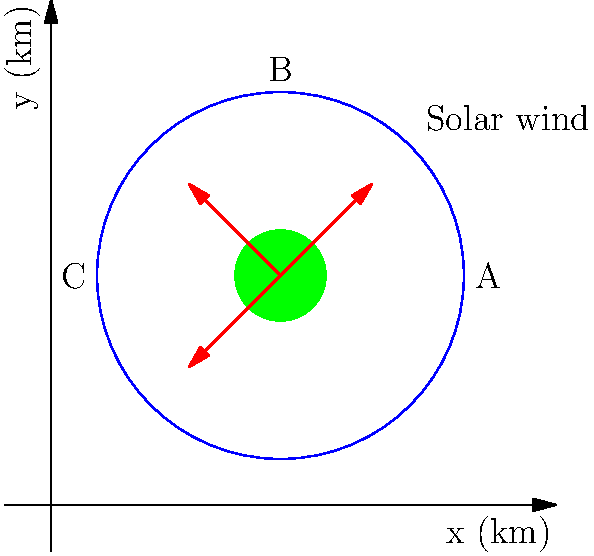A satellite orbits Earth in a circular path with radius 4 km, centered at (5,5) km. Solar wind vectors are shown in red, originating from the Earth's center. Given that the optimal orbital path should minimize exposure to solar wind, calculate the coordinates of the point on the orbit where the satellite should be positioned for minimal solar wind impact. To find the optimal position for the satellite, we need to determine the point on the orbit that is furthest from the solar wind vectors. This can be done by following these steps:

1) The solar wind vectors are pointing towards the upper-right quadrant of the orbit. Therefore, the optimal position will be in the lower-left quadrant.

2) The center of the orbit is at (5,5) km, and the radius is 4 km.

3) The point furthest from the upper-right quadrant will be 225° (or -135°) from the positive x-axis.

4) We can use parametric equations of a circle to find this point:
   $x = x_center + r \cos(\theta)$
   $y = y_center + r \sin(\theta)$

   Where $(x_center, y_center) = (5,5)$, $r = 4$, and $\theta = 225°$ or $\frac{5\pi}{4}$ radians.

5) Plugging in these values:
   $x = 5 + 4 \cos(\frac{5\pi}{4}) = 5 + 4 \cdot (-\frac{\sqrt{2}}{2}) = 5 - 2\sqrt{2}$
   $y = 5 + 4 \sin(\frac{5\pi}{4}) = 5 + 4 \cdot (-\frac{\sqrt{2}}{2}) = 5 - 2\sqrt{2}$

6) Therefore, the optimal position for the satellite is at $(5 - 2\sqrt{2}, 5 - 2\sqrt{2})$ km.
Answer: $(5 - 2\sqrt{2}, 5 - 2\sqrt{2})$ km 